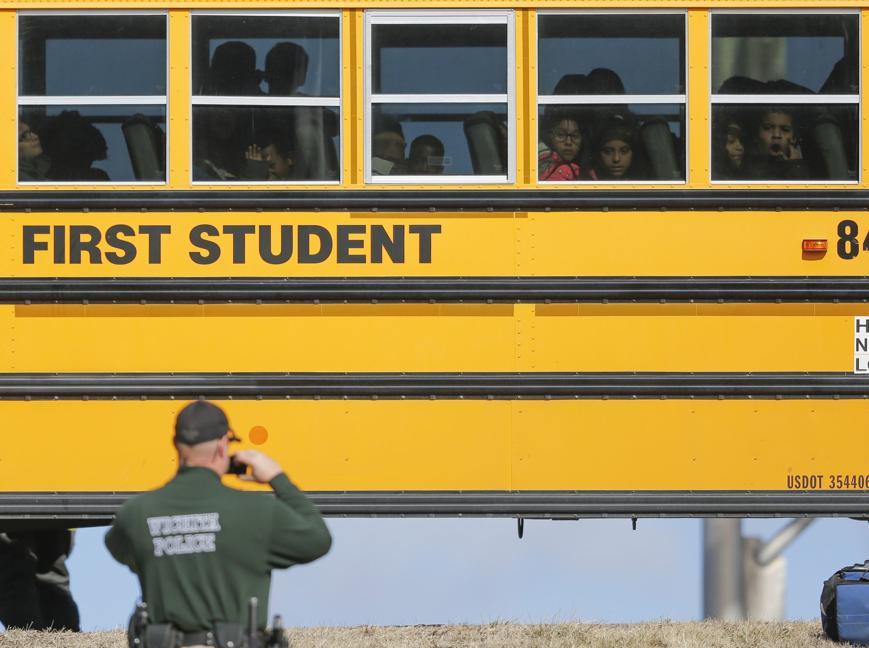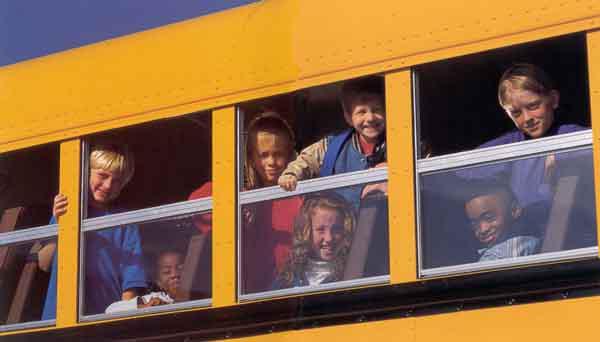The first image is the image on the left, the second image is the image on the right. Evaluate the accuracy of this statement regarding the images: "In one of the images, there is a person standing outside of the bus.". Is it true? Answer yes or no. Yes. The first image is the image on the left, the second image is the image on the right. For the images displayed, is the sentence "In the right image, childrens' heads are peering out of the top half of open bus windows, and at least one hand is gripping a window ledge." factually correct? Answer yes or no. Yes. 